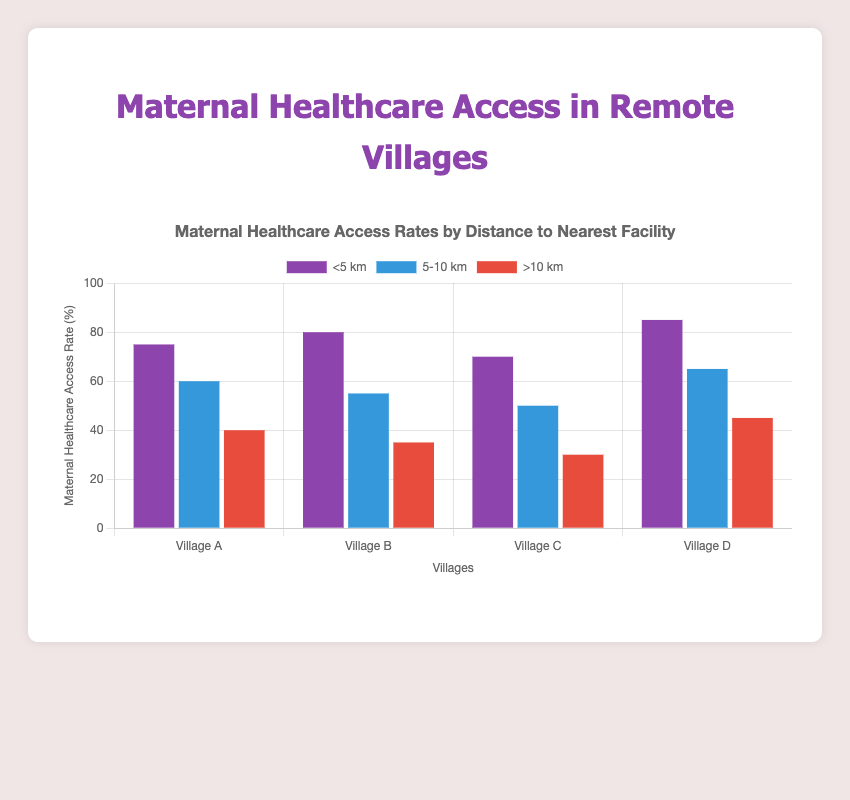What is the maternal healthcare access rate for Village D at a distance of 5-10 km? Refer to the second set of bars (labelled "5-10 km"). For Village D, the bar reaches up to 65 on the y-axis.
Answer: 65 Which village has the highest maternal healthcare access rate for distances greater than 10 km? Compare the height of the bars in the ">10 km" category across all villages. Village D has the highest bar reaching 45 on the y-axis.
Answer: Village D How does the maternal healthcare access rate change in Village B as the distance to the clinic increases? For Village B, observe the three bars in different distance categories. The rate decreases from 80 (<5 km) to 55 (5-10 km) and then to 35 (>10 km).
Answer: Decreases On average, what is the maternal healthcare access rate for distances less than 5 km across all villages? Add the access rates for <5 km across all villages (75 for Village A, 80 for Village B, 70 for Village C, 85 for Village D) and divide by the number of villages (4). Calculation: (75 + 80 + 70 + 85) / 4 = 310 / 4 = 77.5
Answer: 77.5 Which distance category shows the most significant decrease in maternal healthcare access rate from Village C to Village D? Look at the bars for Village C and Village D in each distance category, and calculate the differences: <5 km (85 - 70 = 15), 5-10 km (65 - 50 = 15), >10 km (45 - 30 = 15). All categories show the same decrease of 15.
Answer: All categories; 15 points What is the total maternal healthcare access rate for Village A combining all distance categories? Add the access rates for Village A from all categories: 75 (<5 km) + 60 (5-10 km) + 40 (>10 km). Calculation: 75 + 60 + 40 = 175.
Answer: 175 Which village has the least variation in maternal healthcare access rates across the different distance categories? Find the range (maximum - minimum) of access rates for each village: Village A (75 - 40 = 35), Village B (80 - 35 = 45), Village C (70 - 30 = 40), Village D (85 - 45 = 40). Village A has the smallest range.
Answer: Village A For which two villages is the difference in maternal healthcare access rates largest at a distance of 5-10 km? Compare the bars in the "5-10 km" category. The largest difference is between Village D (65) and Village B (55). Calculation: 65 - 55 = 10.
Answer: Village D and Village B Between Village A and Village C, which village has a lower maternal healthcare access rate for distances greater than 10 km? Compare the height of the bars in the ">10 km" category. Village C's bar is lower at 30 compared to Village A's bar at 40.
Answer: Village C How much higher is the maternal healthcare access rate in Village D for <5 km compared to >10 km? Subtract the access rate for >10 km from the rate for <5 km in Village D. Calculation: 85 - 45 = 40.
Answer: 40 